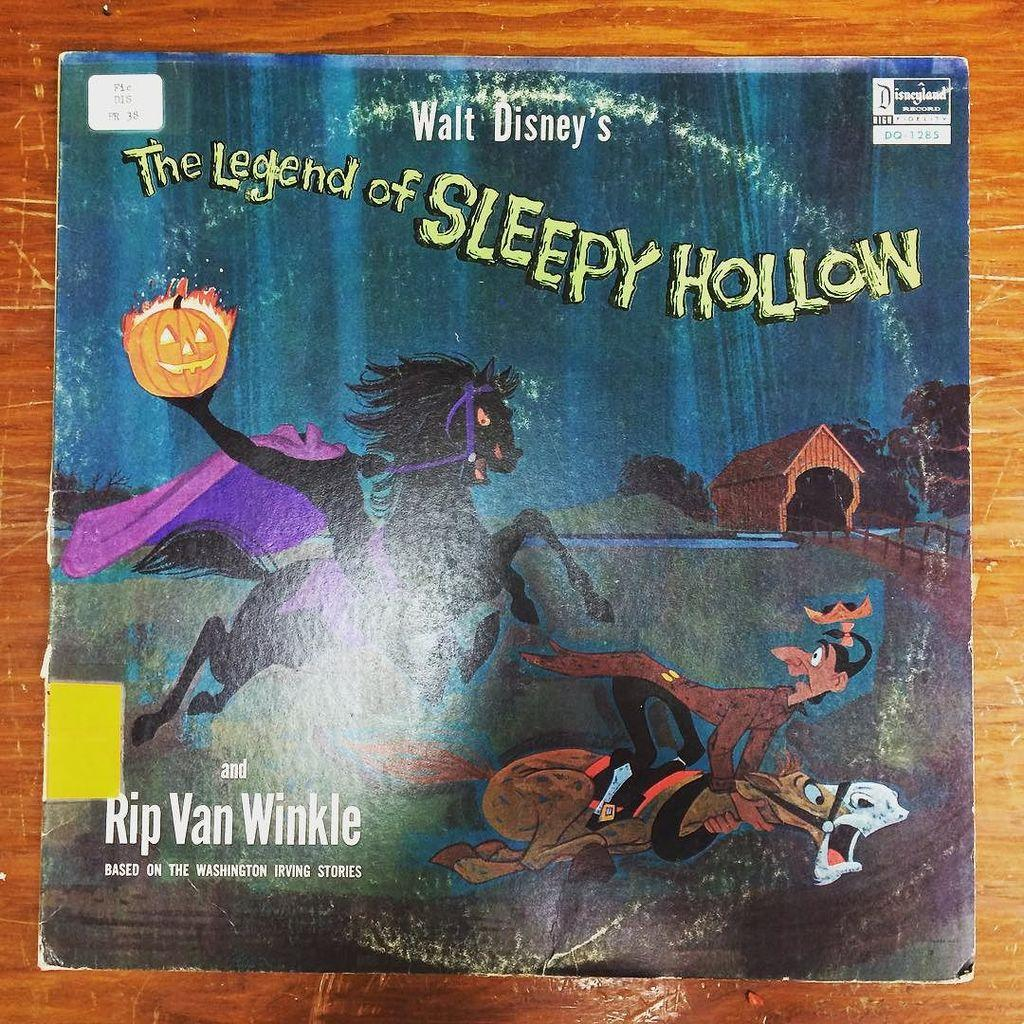<image>
Give a short and clear explanation of the subsequent image. A book from Walt Disney with a horse on the cover is titled The Legend of Sleepy Hollow. 